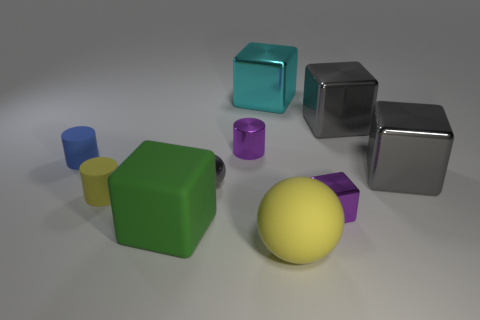Are there any gray rubber spheres that have the same size as the rubber cube?
Provide a succinct answer. No. What is the material of the cylinder that is left of the small yellow matte thing?
Offer a very short reply. Rubber. Is the material of the purple cube behind the big sphere the same as the purple cylinder?
Give a very brief answer. Yes. There is a yellow matte object that is the same size as the cyan shiny thing; what shape is it?
Make the answer very short. Sphere. How many objects are the same color as the rubber ball?
Give a very brief answer. 1. Is the number of big cyan metal things in front of the blue object less than the number of tiny purple shiny things in front of the tiny sphere?
Your answer should be compact. Yes. Are there any blue objects in front of the tiny purple cylinder?
Provide a succinct answer. Yes. Are there any cyan metal things behind the purple shiny thing to the right of the object that is in front of the big green rubber block?
Your answer should be very brief. Yes. Does the purple metal object behind the small blue cylinder have the same shape as the small blue rubber object?
Offer a very short reply. Yes. What color is the tiny cylinder that is the same material as the large cyan cube?
Make the answer very short. Purple. 